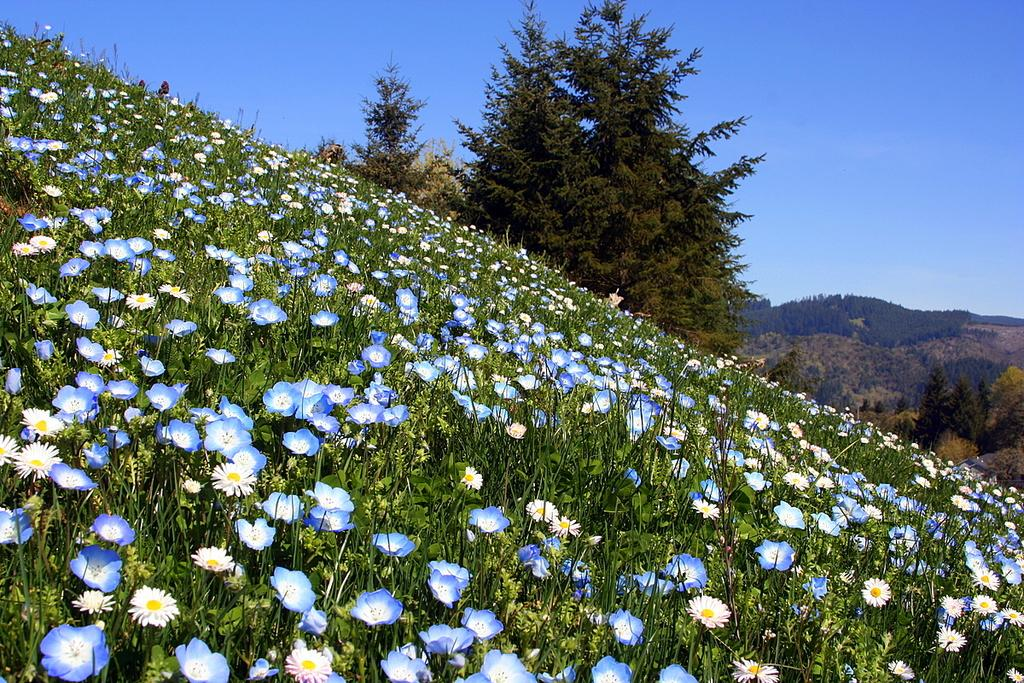What type of vegetation can be seen in the image? There are trees in the image. What other natural elements are present in the image? There are flowers in the image. What colors are the flowers? The flowers are in white, yellow, and blue colors. What is the color of the sky in the image? The sky is blue in the image. Can you see any quivers in the image? There is no quiver present in the image. Are there any cobwebs visible in the image? There is no cobweb present in the image. 